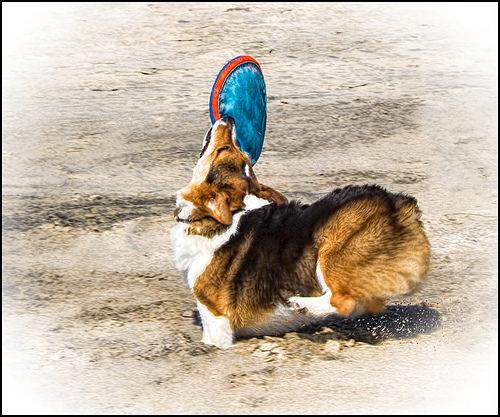<image>
Can you confirm if the dog is under the frisbee? Yes. The dog is positioned underneath the frisbee, with the frisbee above it in the vertical space. Is there a frisbee above the dog? Yes. The frisbee is positioned above the dog in the vertical space, higher up in the scene. 